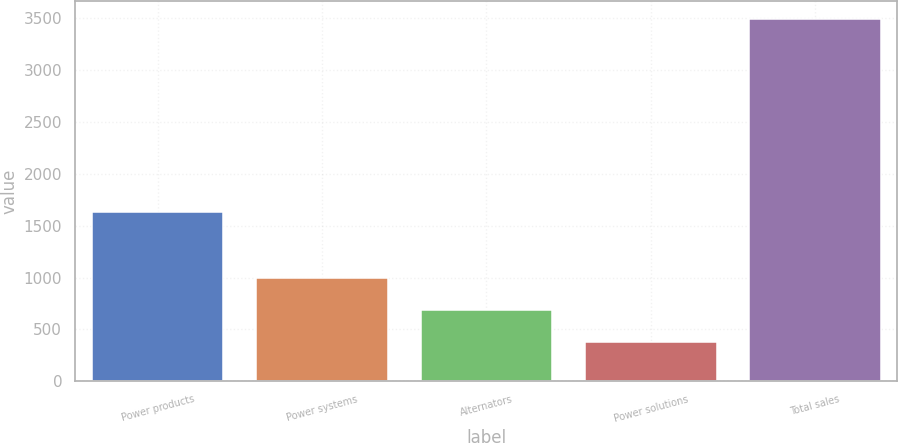Convert chart. <chart><loc_0><loc_0><loc_500><loc_500><bar_chart><fcel>Power products<fcel>Power systems<fcel>Alternators<fcel>Power solutions<fcel>Total sales<nl><fcel>1636<fcel>998.8<fcel>686.4<fcel>374<fcel>3498<nl></chart> 